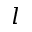<formula> <loc_0><loc_0><loc_500><loc_500>l</formula> 